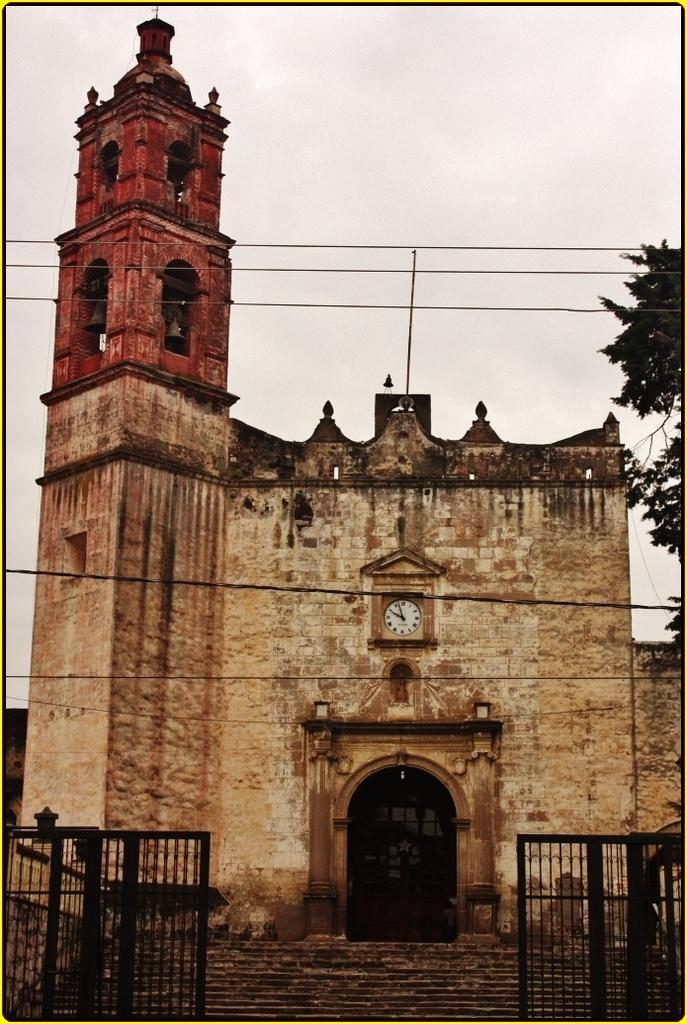What type of structure is present in the image? There is a building in the image. What feature of the building is mentioned in the facts? The building has a door. What time-related object is visible in the image? There is a clock in the image. What architectural element is present at the bottom of the image? There is a gate at the bottom of the image. Are there any steps associated with the gate? Yes, there are steps associated with the gate. What type of vegetation can be seen on the right side of the image? There is a tree on the right side of the image. What part of the natural environment is visible in the image? The sky is visible at the top of the image. What type of breakfast is being served in the image? There is no breakfast visible in the image. Can you tell me how many deer are present in the image? There are no deer present in the image. 